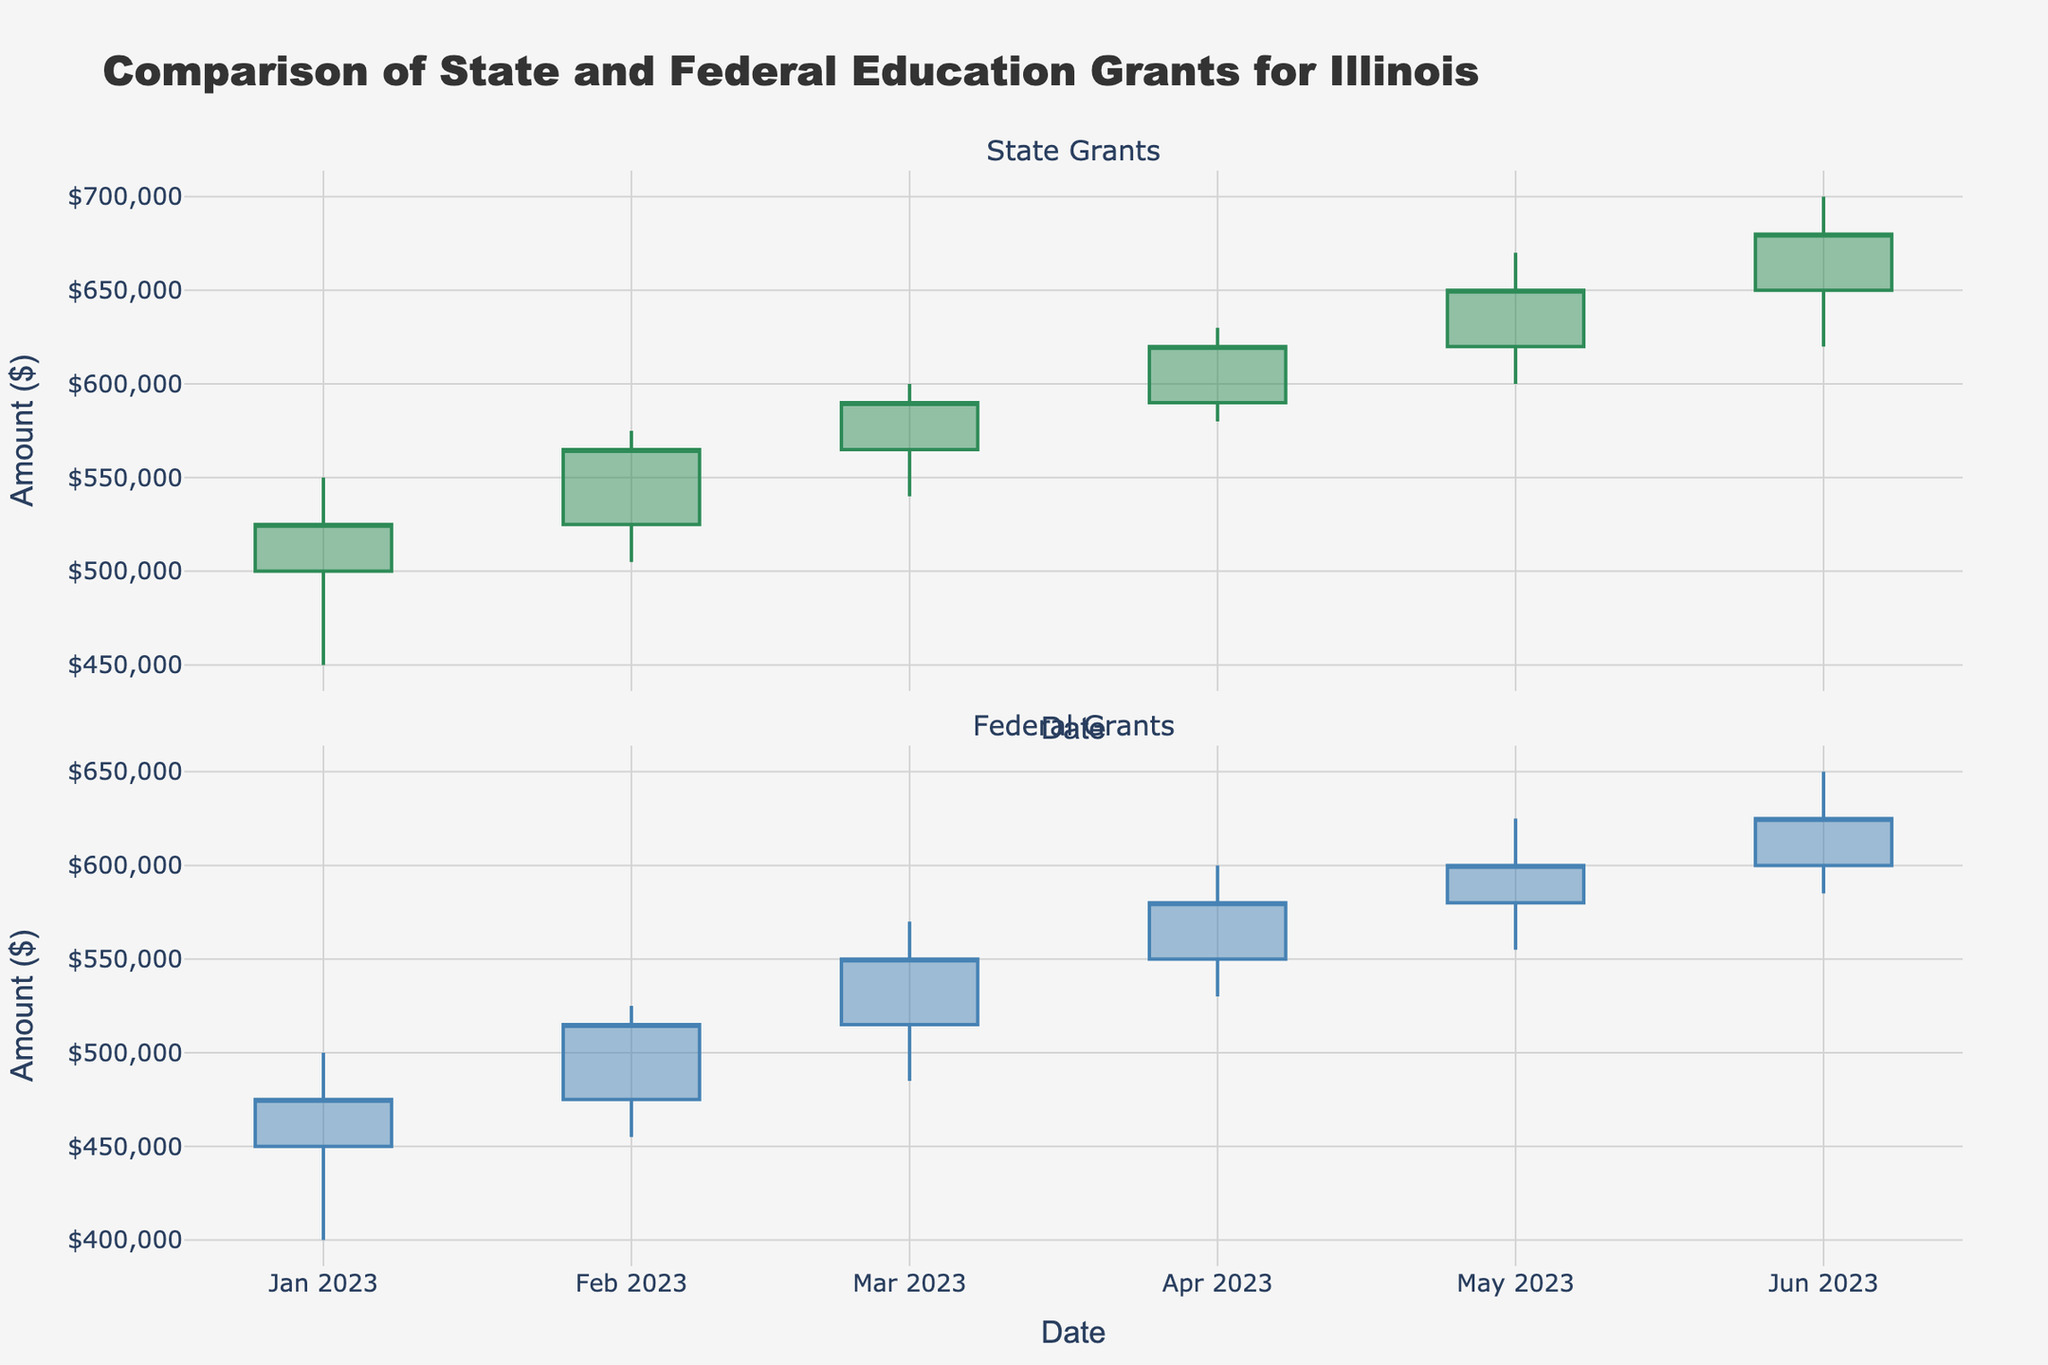What is the title of the figure? The title is usually located at the top center of the figure. It provides an overview of what the plot represents.
Answer: "Comparison of State and Federal Education Grants for Illinois" How many data points are shown for each grant type? Each candlestick represents a data point. We observe one candlestick per month for each grant type from January to June, resulting in 6 data points per grant type.
Answer: 6 What does the y-axis represent in the figure? The y-axis title typically describes the quantity measured. In this figure, it is labeled "Amount ($)" which indicates that the vertical axis measures the amount of grants in dollars.
Answer: Amount ($) Which month shows the highest closing value for State Grants? To find the highest closing value for State Grants, look for the candlestick with the highest close position horizontally along the y-axis. This is seen in June.
Answer: June Which month has the largest difference between the high and low values for Federal Grants? For Federal Grants, observe the vertical length of candlesticks from high to low values. The largest difference is indicated by the longest candlestick, which is in March.
Answer: March What are the increasing and decreasing line colors for Federal Grants? Candlestick colors indicate whether the closing price was higher or lower than the opening price. For Federal Grants, increasing lines are blue and decreasing lines are dark red.
Answer: Blue and dark red In which month did both State and Federal Grants show an increasing trend? A month showing an increasing trend will have both the State and Federal candlesticks in green. This is observed in March, April, and June.
Answer: March, April, and June Which grant type has a higher closing value in February? Look at the closing values of State and Federal Grants candlesticks for February. State Grants close at 565,000 while Federal Grants close at 515,000.
Answer: State Grants What is the trend of Federal Grants from January to June? To observe the trend, review the closing values over the months. The closing values generally increased each month, indicating an upward trend.
Answer: Upward trend 